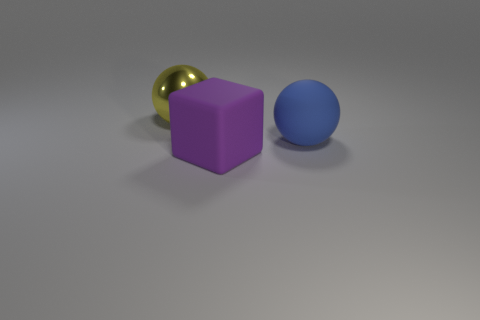Is there any other thing that has the same material as the large yellow ball?
Keep it short and to the point. No. How many other objects are the same size as the block?
Provide a short and direct response. 2. What is the object that is to the left of the big blue rubber object and behind the big purple block made of?
Keep it short and to the point. Metal. What number of purple rubber things are behind the blue matte thing?
Your answer should be compact. 0. How many big rubber things are there?
Offer a terse response. 2. Is the size of the blue matte object the same as the metal ball?
Your response must be concise. Yes. Are there any large yellow shiny spheres behind the large shiny ball behind the sphere that is in front of the large yellow metal thing?
Give a very brief answer. No. There is another thing that is the same shape as the blue rubber object; what material is it?
Ensure brevity in your answer.  Metal. What color is the object that is in front of the large blue thing?
Give a very brief answer. Purple. What size is the yellow object?
Provide a succinct answer. Large. 